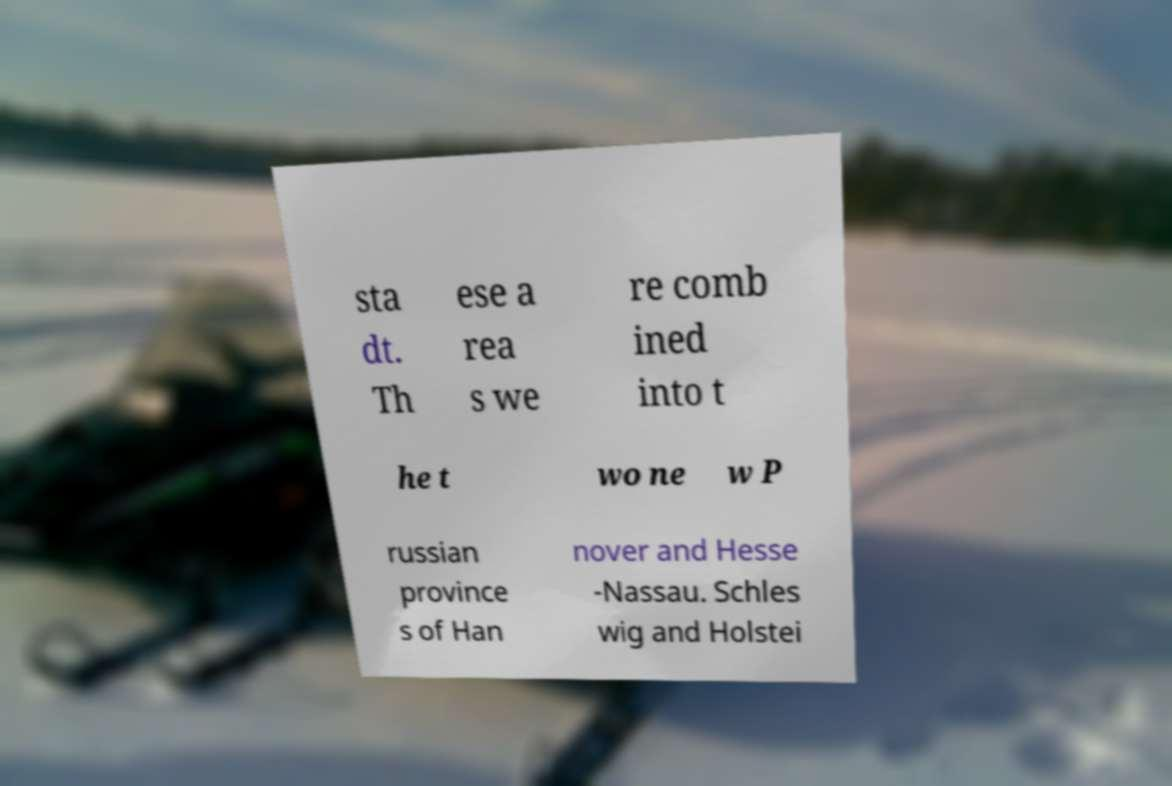For documentation purposes, I need the text within this image transcribed. Could you provide that? sta dt. Th ese a rea s we re comb ined into t he t wo ne w P russian province s of Han nover and Hesse -Nassau. Schles wig and Holstei 